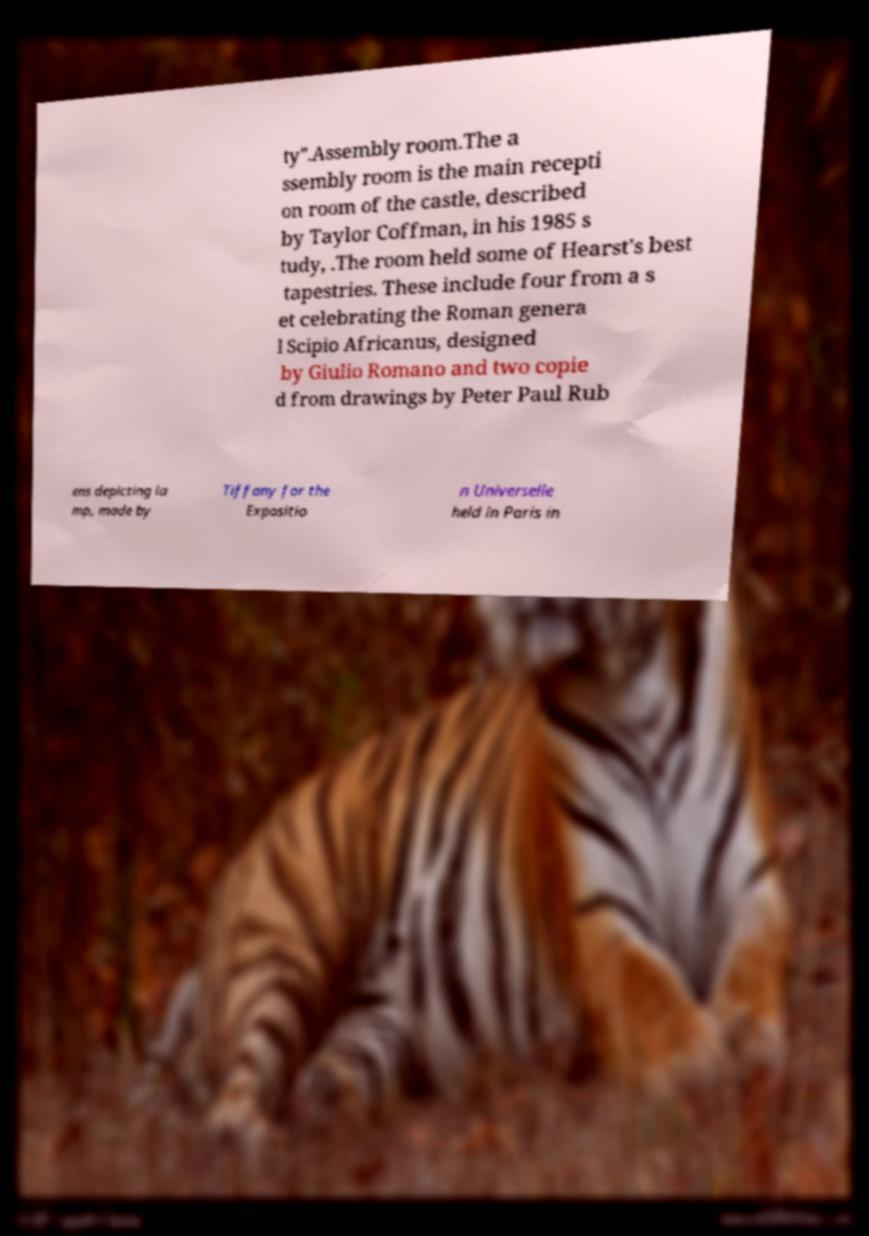Please read and relay the text visible in this image. What does it say? ty".Assembly room.The a ssembly room is the main recepti on room of the castle, described by Taylor Coffman, in his 1985 s tudy, .The room held some of Hearst's best tapestries. These include four from a s et celebrating the Roman genera l Scipio Africanus, designed by Giulio Romano and two copie d from drawings by Peter Paul Rub ens depicting la mp, made by Tiffany for the Expositio n Universelle held in Paris in 